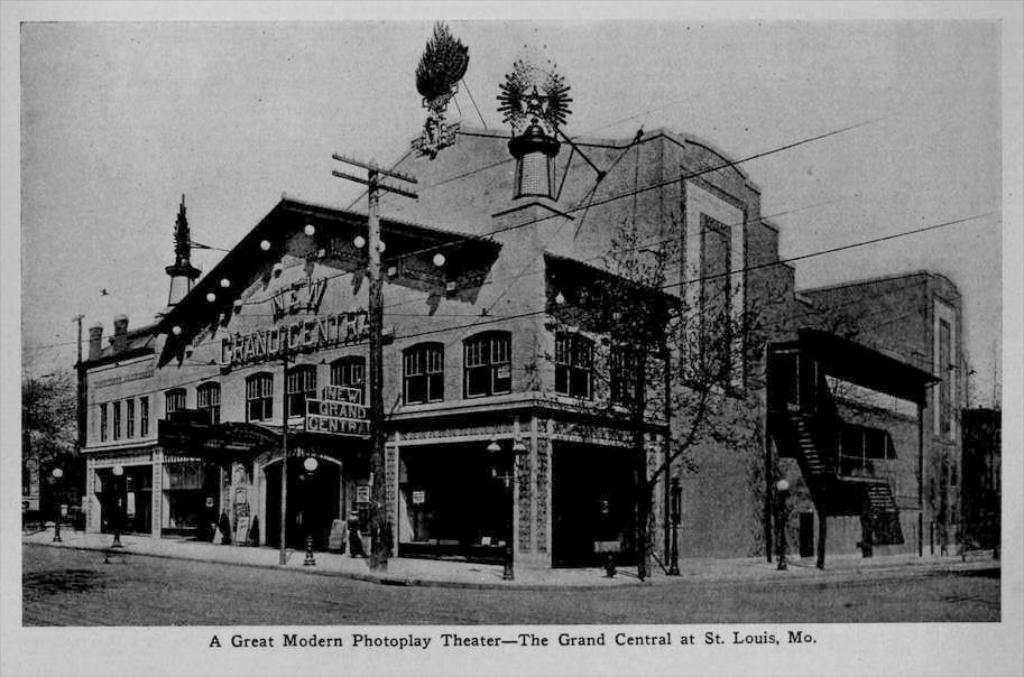Please provide a concise description of this image. This is a black and white image. In this image we can see the picture of a building with windows. We can also see some lights, trees, an utility pole with wires, some poles and the sky which looks cloudy. On the bottom of the image we can see some text. 